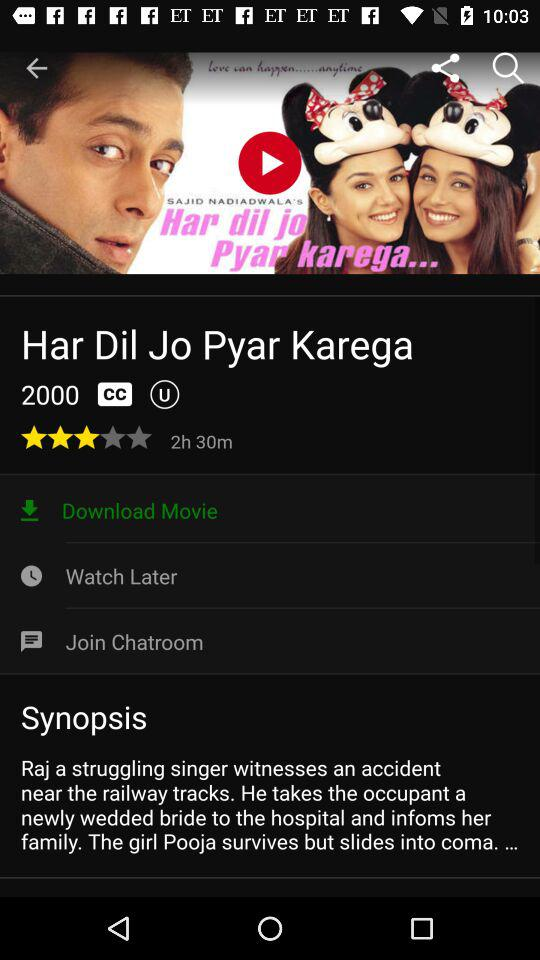What is the movie name? The movie name is "Har Dil Jo Pyar Karega". 